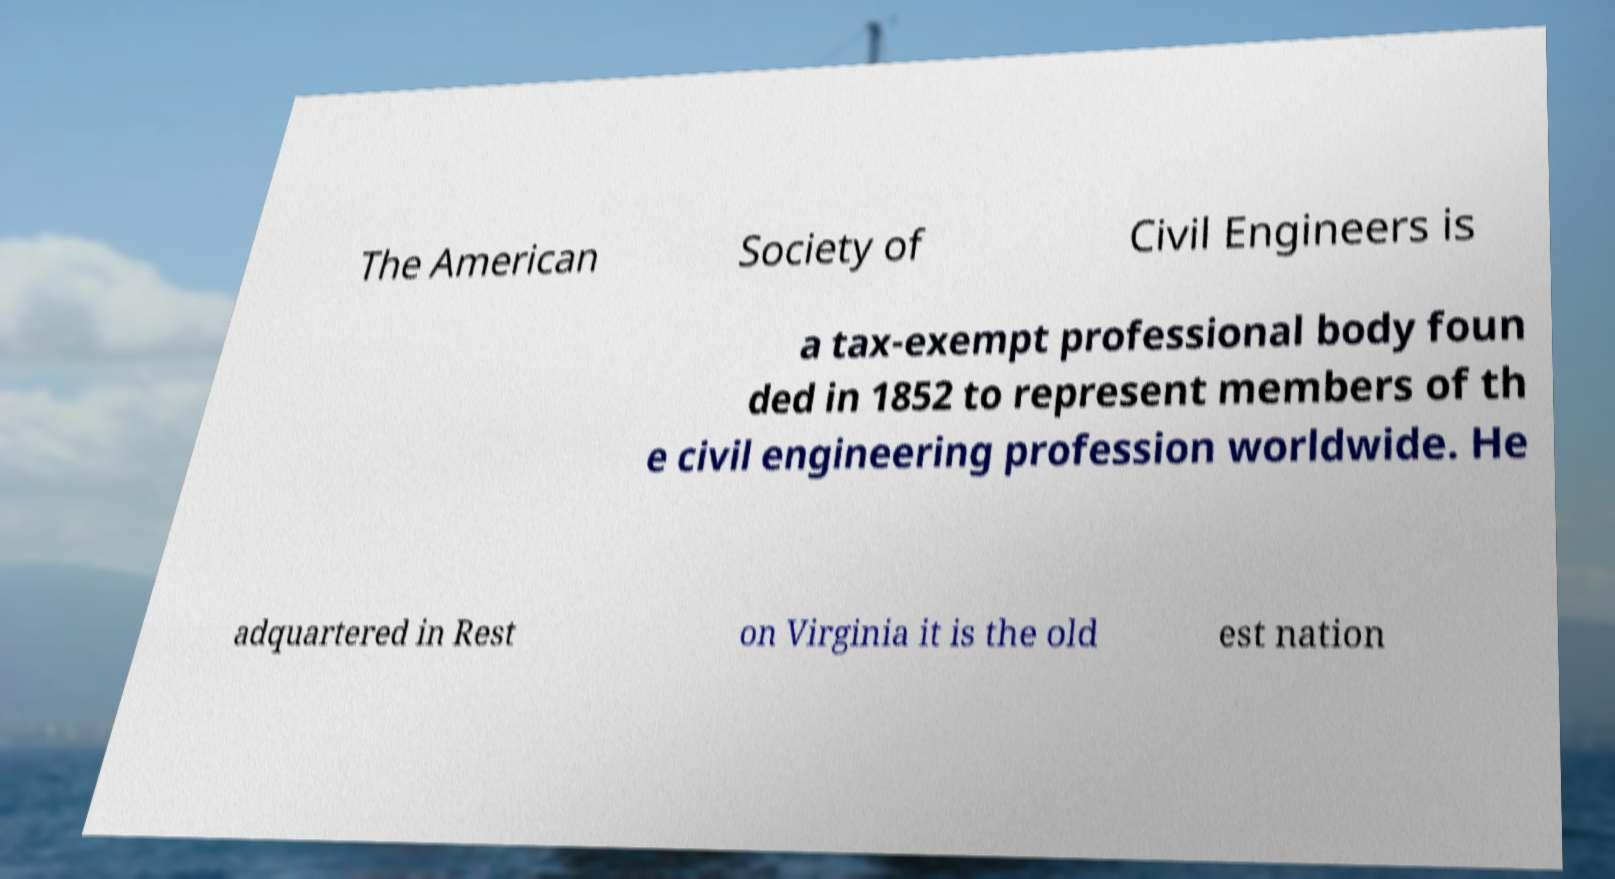I need the written content from this picture converted into text. Can you do that? The American Society of Civil Engineers is a tax-exempt professional body foun ded in 1852 to represent members of th e civil engineering profession worldwide. He adquartered in Rest on Virginia it is the old est nation 